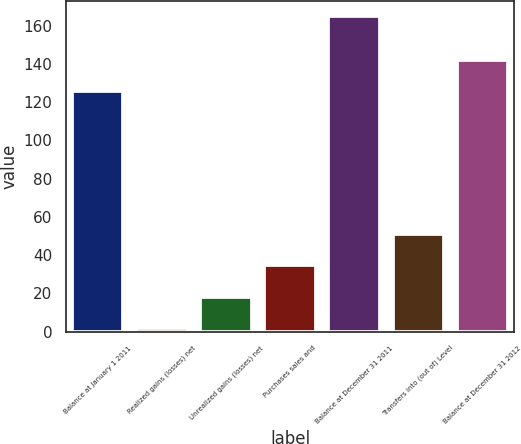Convert chart. <chart><loc_0><loc_0><loc_500><loc_500><bar_chart><fcel>Balance at January 1 2011<fcel>Realized gains (losses) net<fcel>Unrealized gains (losses) net<fcel>Purchases sales and<fcel>Balance at December 31 2011<fcel>Transfers into (out of) Level<fcel>Balance at December 31 2012<nl><fcel>126<fcel>2<fcel>18.3<fcel>34.6<fcel>165<fcel>50.9<fcel>142.3<nl></chart> 